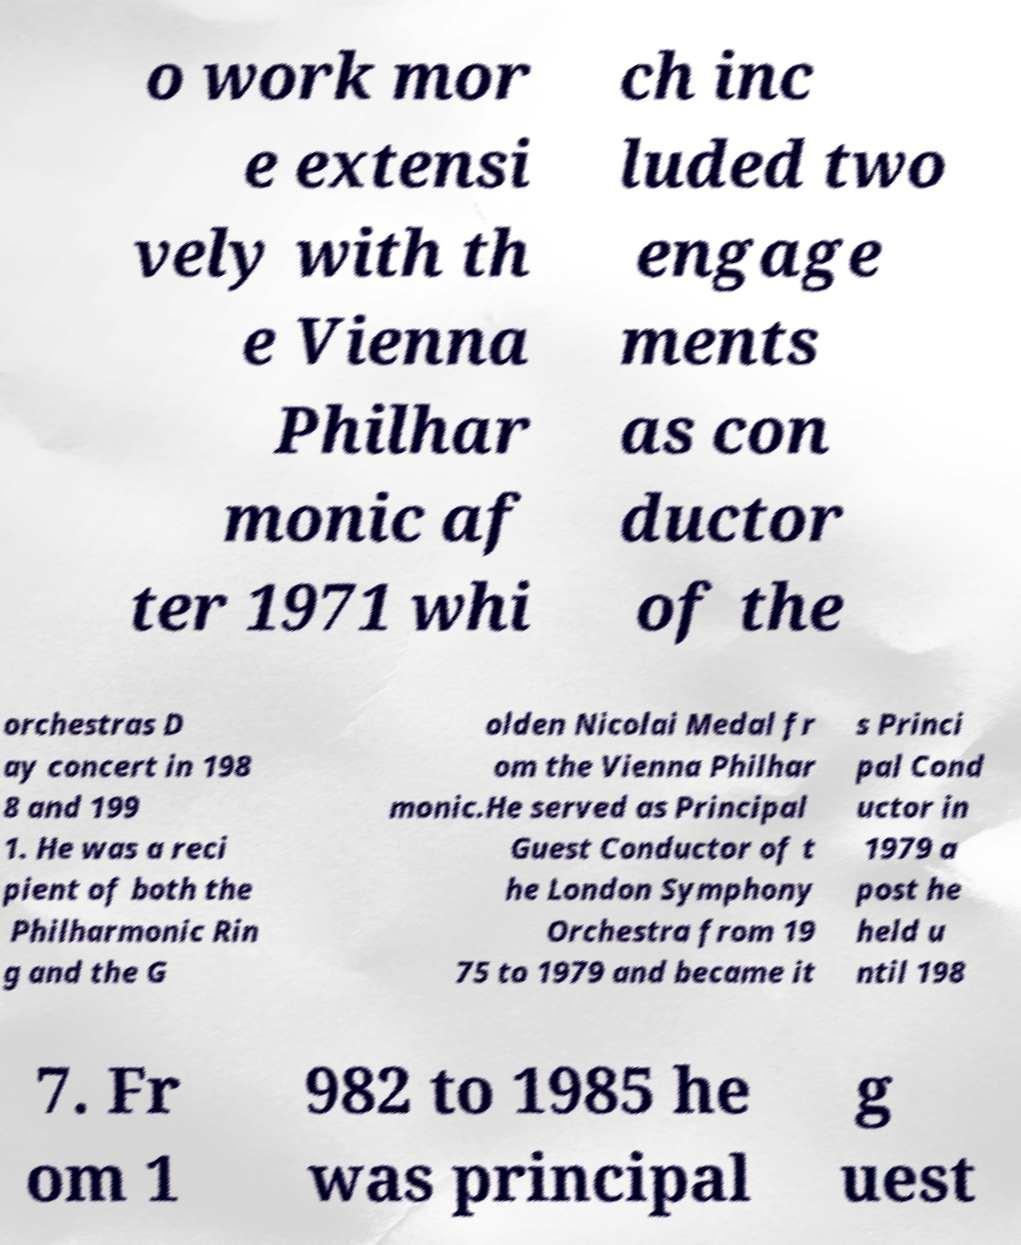I need the written content from this picture converted into text. Can you do that? o work mor e extensi vely with th e Vienna Philhar monic af ter 1971 whi ch inc luded two engage ments as con ductor of the orchestras D ay concert in 198 8 and 199 1. He was a reci pient of both the Philharmonic Rin g and the G olden Nicolai Medal fr om the Vienna Philhar monic.He served as Principal Guest Conductor of t he London Symphony Orchestra from 19 75 to 1979 and became it s Princi pal Cond uctor in 1979 a post he held u ntil 198 7. Fr om 1 982 to 1985 he was principal g uest 